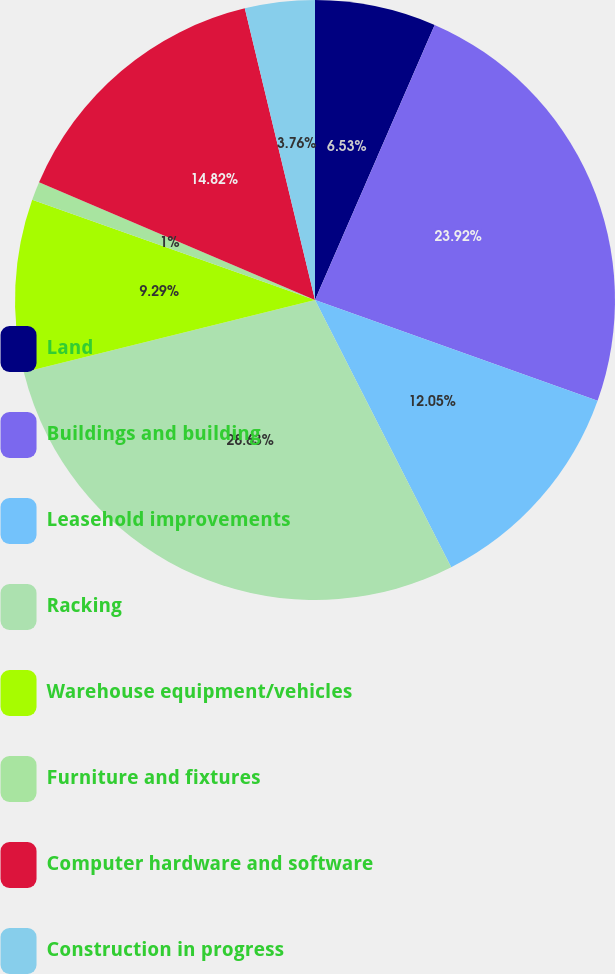Convert chart to OTSL. <chart><loc_0><loc_0><loc_500><loc_500><pie_chart><fcel>Land<fcel>Buildings and building<fcel>Leasehold improvements<fcel>Racking<fcel>Warehouse equipment/vehicles<fcel>Furniture and fixtures<fcel>Computer hardware and software<fcel>Construction in progress<nl><fcel>6.53%<fcel>23.92%<fcel>12.05%<fcel>28.63%<fcel>9.29%<fcel>1.0%<fcel>14.82%<fcel>3.76%<nl></chart> 